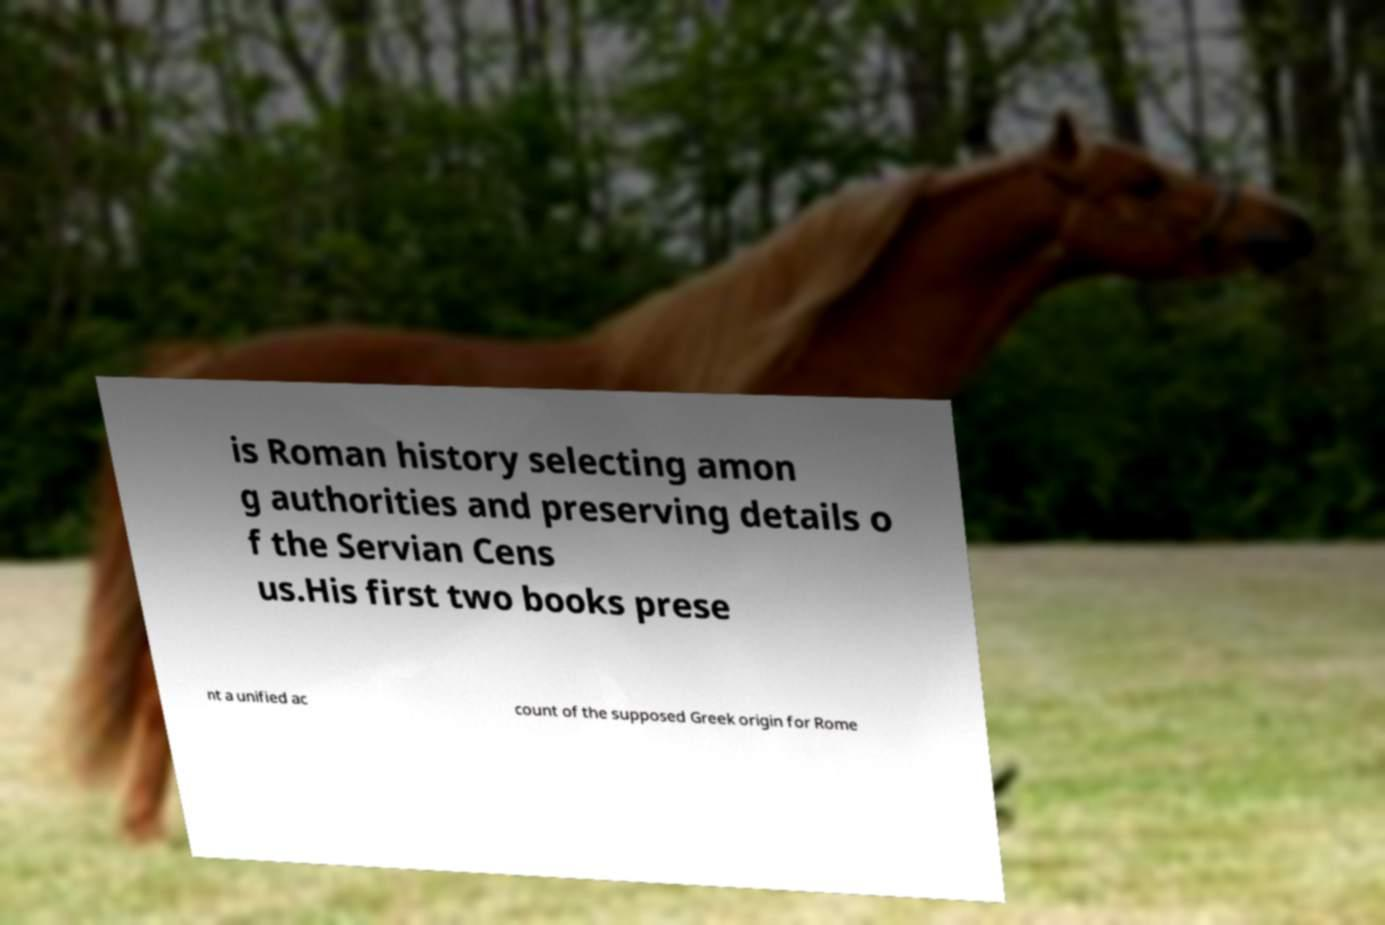Could you assist in decoding the text presented in this image and type it out clearly? is Roman history selecting amon g authorities and preserving details o f the Servian Cens us.His first two books prese nt a unified ac count of the supposed Greek origin for Rome 